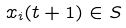Convert formula to latex. <formula><loc_0><loc_0><loc_500><loc_500>x _ { i } ( t + 1 ) \in S</formula> 